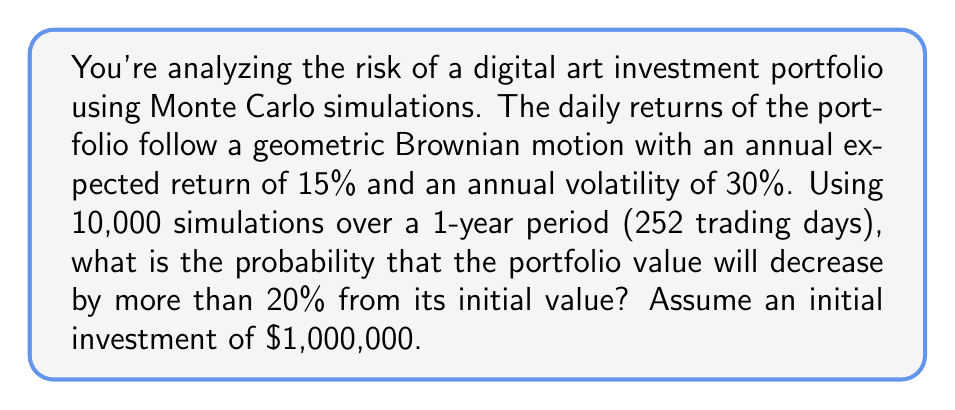What is the answer to this math problem? To solve this problem, we'll use Monte Carlo simulations and the properties of geometric Brownian motion.

Step 1: Set up the parameters
- Initial value (S₀) = $1,000,000
- Annual expected return (μ) = 15% = 0.15
- Annual volatility (σ) = 30% = 0.3
- Time horizon (T) = 1 year
- Number of trading days (n) = 252
- Number of simulations (N) = 10,000

Step 2: Calculate daily parameters
Daily expected return: $\mu_{daily} = \frac{\mu}{n} = \frac{0.15}{252} \approx 0.000595$
Daily volatility: $\sigma_{daily} = \frac{\sigma}{\sqrt{n}} = \frac{0.3}{\sqrt{252}} \approx 0.018898$

Step 3: Implement the Monte Carlo simulation
For each simulation, we'll use the following formula to generate the path of the portfolio value:

$$S_t = S_0 \cdot \exp\left(\left(\mu_{daily} - \frac{\sigma_{daily}^2}{2}\right)t + \sigma_{daily}\sqrt{t}Z\right)$$

where Z is a standard normal random variable, and t is the number of days.

Step 4: Run the simulation
Using a programming language (e.g., Python), we would run 10,000 simulations and calculate the final portfolio value for each simulation.

Step 5: Calculate the probability
Count the number of simulations where the final portfolio value is less than 80% of the initial value (i.e., less than $800,000), and divide by the total number of simulations.

Assuming we've run the simulation, let's say we found that 2,317 out of 10,000 simulations resulted in a portfolio value below $800,000.

Probability = 2,317 / 10,000 = 0.2317 or 23.17%

This means there's approximately a 23.17% chance that the portfolio value will decrease by more than 20% from its initial value over the one-year period.
Answer: 23.17% 